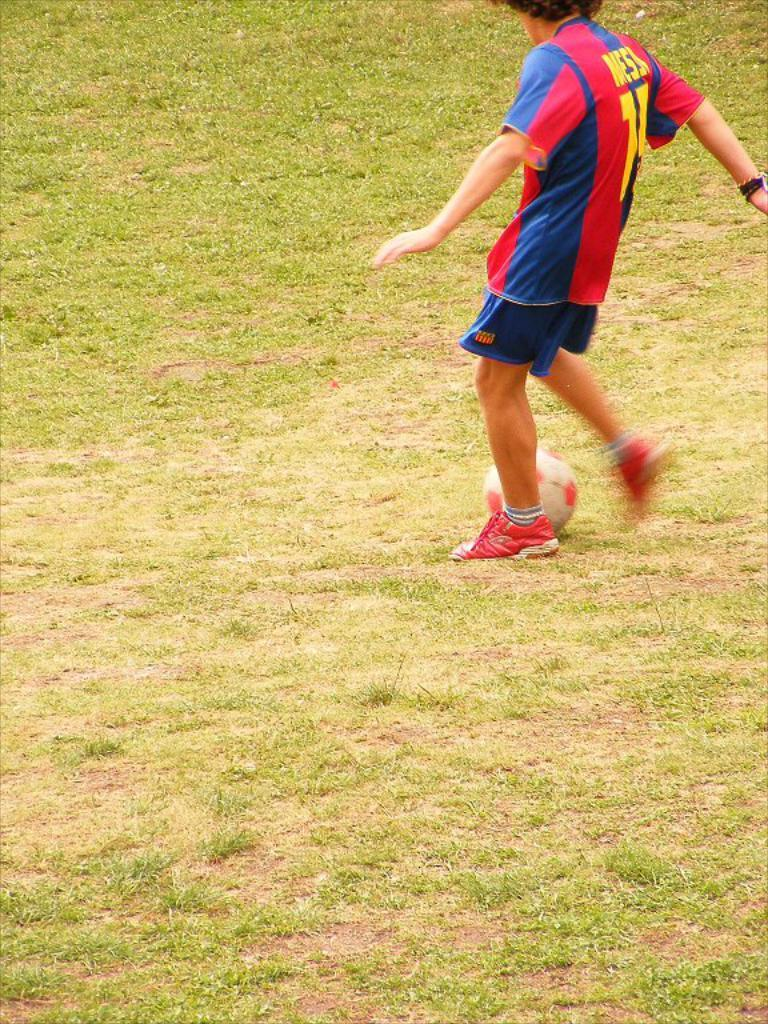<image>
Write a terse but informative summary of the picture. A small boy wearing  A Barcelona FC strip with Messi on the back kicks a ball. 